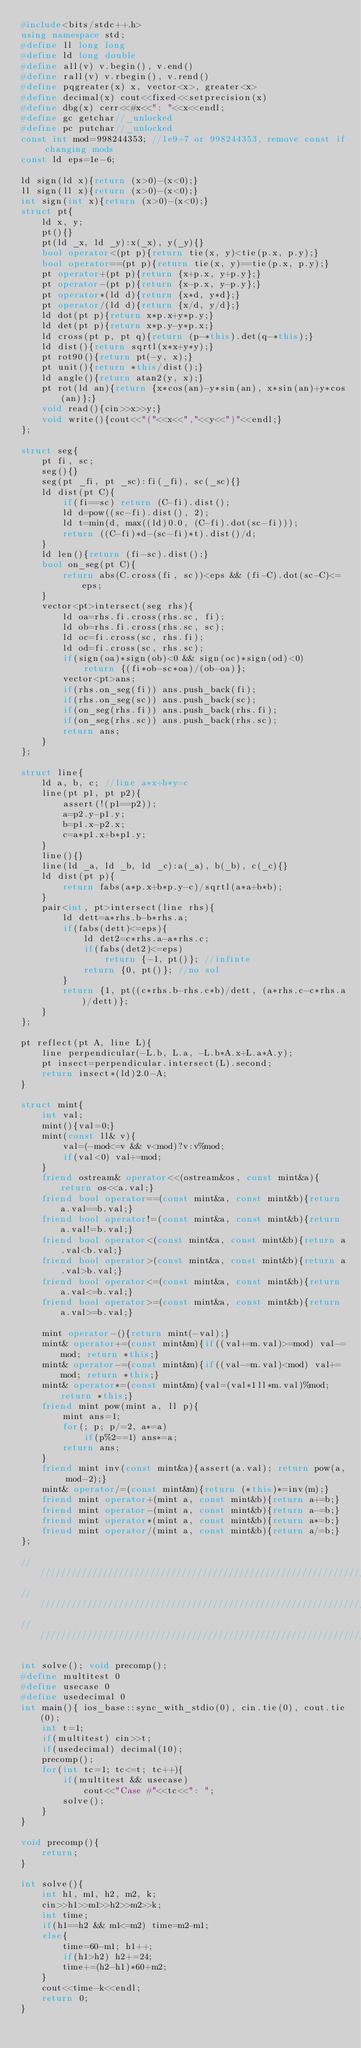Convert code to text. <code><loc_0><loc_0><loc_500><loc_500><_C++_>#include<bits/stdc++.h>
using namespace std;
#define ll long long
#define ld long double
#define all(v) v.begin(), v.end()
#define rall(v) v.rbegin(), v.rend()
#define pqgreater(x) x, vector<x>, greater<x>
#define decimal(x) cout<<fixed<<setprecision(x)
#define dbg(x) cerr<<#x<<": "<<x<<endl;
#define gc getchar//_unlocked
#define pc putchar//_unlocked
const int mod=998244353; //1e9+7 or 998244353, remove const if changing mods
const ld eps=1e-6;

ld sign(ld x){return (x>0)-(x<0);}
ll sign(ll x){return (x>0)-(x<0);}
int sign(int x){return (x>0)-(x<0);}
struct pt{
	ld x, y;
	pt(){}
	pt(ld _x, ld _y):x(_x), y(_y){}
	bool operator<(pt p){return tie(x, y)<tie(p.x, p.y);}
	bool operator==(pt p){return tie(x, y)==tie(p.x, p.y);}
	pt operator+(pt p){return {x+p.x, y+p.y};}
	pt operator-(pt p){return {x-p.x, y-p.y};}
	pt operator*(ld d){return {x*d, y*d};}
	pt operator/(ld d){return {x/d, y/d};}
	ld dot(pt p){return x*p.x+y*p.y;}
	ld det(pt p){return x*p.y-y*p.x;}
	ld cross(pt p, pt q){return (p-*this).det(q-*this);}
	ld dist(){return sqrtl(x*x+y*y);}
	pt rot90(){return pt(-y, x);}
	pt unit(){return *this/dist();}
	ld angle(){return atan2(y, x);}
	pt rot(ld an){return {x*cos(an)-y*sin(an), x*sin(an)+y*cos(an)};}
	void read(){cin>>x>>y;}
	void write(){cout<<"("<<x<<","<<y<<")"<<endl;}
};

struct seg{
	pt fi, sc;
	seg(){}
	seg(pt _fi, pt _sc):fi(_fi), sc(_sc){}
	ld dist(pt C){
		if(fi==sc) return (C-fi).dist();
		ld d=pow((sc-fi).dist(), 2);
		ld t=min(d, max((ld)0.0, (C-fi).dot(sc-fi)));
		return ((C-fi)*d-(sc-fi)*t).dist()/d;
	}
	ld len(){return (fi-sc).dist();}
	bool on_seg(pt C){
		return abs(C.cross(fi, sc))<eps && (fi-C).dot(sc-C)<=eps;
	}
	vector<pt>intersect(seg rhs){
		ld oa=rhs.fi.cross(rhs.sc, fi);
		ld ob=rhs.fi.cross(rhs.sc, sc);
		ld oc=fi.cross(sc, rhs.fi);
		ld od=fi.cross(sc, rhs.sc);
		if(sign(oa)*sign(ob)<0 && sign(oc)*sign(od)<0)
			return {(fi*ob-sc*oa)/(ob-oa)};
		vector<pt>ans;
		if(rhs.on_seg(fi)) ans.push_back(fi);
		if(rhs.on_seg(sc)) ans.push_back(sc);
		if(on_seg(rhs.fi)) ans.push_back(rhs.fi);
		if(on_seg(rhs.sc)) ans.push_back(rhs.sc);
		return ans;
	}
};

struct line{
	ld a, b, c; //line a*x+b*y=c
	line(pt p1, pt p2){
		assert(!(p1==p2));
		a=p2.y-p1.y;
		b=p1.x-p2.x;
		c=a*p1.x+b*p1.y;
	}
	line(){}
	line(ld _a, ld _b, ld _c):a(_a), b(_b), c(_c){}
	ld dist(pt p){
		return fabs(a*p.x+b*p.y-c)/sqrtl(a*a+b*b);
	}
	pair<int, pt>intersect(line rhs){
		ld dett=a*rhs.b-b*rhs.a;
		if(fabs(dett)<=eps){
			ld det2=c*rhs.a-a*rhs.c;
			if(fabs(det2)<=eps)
				return {-1, pt()}; //infinte
			return {0, pt()}; //no sol
		}
		return {1, pt((c*rhs.b-rhs.c*b)/dett, (a*rhs.c-c*rhs.a)/dett)};
	}
};

pt reflect(pt A, line L){
	line perpendicular(-L.b, L.a, -L.b*A.x+L.a*A.y);
	pt insect=perpendicular.intersect(L).second;
	return insect*(ld)2.0-A;
}

struct mint{
	int val;
	mint(){val=0;}
	mint(const ll& v){
		val=(-mod<=v && v<mod)?v:v%mod;
		if(val<0) val+=mod;
	}
	friend ostream& operator<<(ostream&os, const mint&a){return os<<a.val;}
	friend bool operator==(const mint&a, const mint&b){return a.val==b.val;}
	friend bool operator!=(const mint&a, const mint&b){return a.val!=b.val;}
	friend bool operator<(const mint&a, const mint&b){return a.val<b.val;}
	friend bool operator>(const mint&a, const mint&b){return a.val>b.val;}
	friend bool operator<=(const mint&a, const mint&b){return a.val<=b.val;}
	friend bool operator>=(const mint&a, const mint&b){return a.val>=b.val;}

	mint operator-(){return mint(-val);}
	mint& operator+=(const mint&m){if((val+=m.val)>=mod) val-=mod; return *this;}
	mint& operator-=(const mint&m){if((val-=m.val)<mod) val+=mod; return *this;}
	mint& operator*=(const mint&m){val=(val*1ll*m.val)%mod; return *this;}
	friend mint pow(mint a, ll p){
		mint ans=1;
		for(; p; p/=2, a*=a)
			if(p%2==1) ans*=a;
		return ans;
	}
	friend mint inv(const mint&a){assert(a.val); return pow(a, mod-2);}
	mint& operator/=(const mint&m){return (*this)*=inv(m);}
	friend mint operator+(mint a, const mint&b){return a+=b;}
	friend mint operator-(mint a, const mint&b){return a-=b;}
	friend mint operator*(mint a, const mint&b){return a*=b;}
	friend mint operator/(mint a, const mint&b){return a/=b;}
};

/////////////////////////////////////////////////////////////////////////////////////////////////
/////////////////////////////////////////////////////////////////////////////////////////////////
/////////////////////////////////////////////////////////////////////////////////////////////////

int solve(); void precomp();
#define multitest 0
#define usecase 0
#define usedecimal 0
int main(){ ios_base::sync_with_stdio(0), cin.tie(0), cout.tie(0);
	int t=1;
	if(multitest) cin>>t;
	if(usedecimal) decimal(10);
	precomp();
	for(int tc=1; tc<=t; tc++){
		if(multitest && usecase)
			cout<<"Case #"<<tc<<": ";
		solve();
	}
}

void precomp(){
	return;
}

int solve(){
	int h1, m1, h2, m2, k;
	cin>>h1>>m1>>h2>>m2>>k;
	int time;
	if(h1==h2 && m1<=m2) time=m2-m1;
	else{
		time=60-m1; h1++;
		if(h1>h2) h2+=24;
		time+=(h2-h1)*60+m2;
	}
	cout<<time-k<<endl;
	return 0;
}</code> 